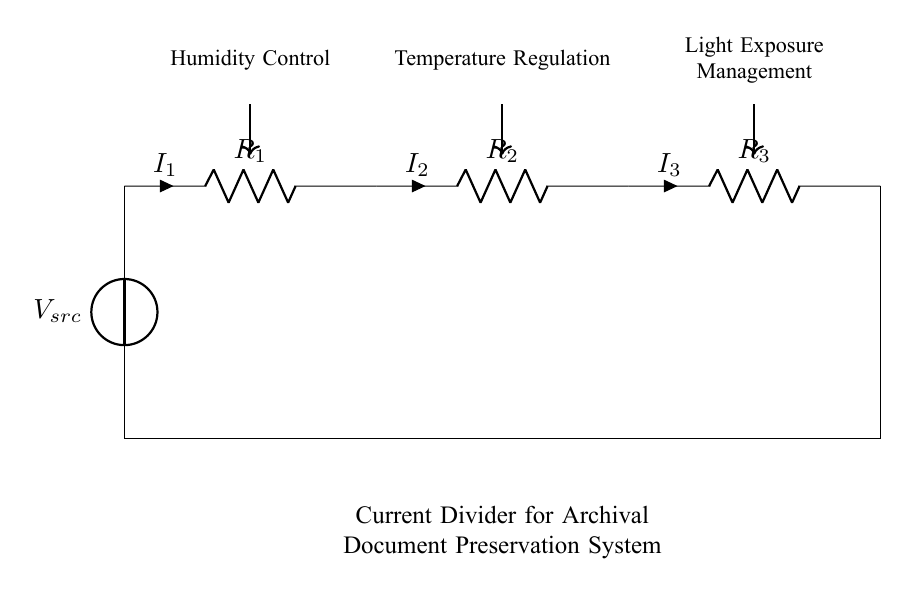What is the type of this circuit? The circuit is a current divider since it splits the total current into smaller currents across multiple resistors in parallel.
Answer: Current divider What components are present in this circuit? The key components in this circuit are resistors and a voltage source; the resistors are labeled R1, R2, and R3, and there is a voltage source Vsrc.
Answer: Resistors and a voltage source How many resistors are involved in the current division? There are three resistors labeled R1, R2, and R3 involved in the current division of the circuit.
Answer: Three resistors What does the diagram illustrate in relation to archival preservation? The diagram illustrates the management of environmental factors such as humidity, temperature, and light exposure for preserving archival documents.
Answer: Environmental management Which resistor would receive the most current? The resistor with the lowest resistance value will receive the most current; however, specific resistance values are not provided in the illustration.
Answer: Lowest resistor (not specified) What is the purpose of a current divider in this context? The purpose is to ensure that the components regulating humidity, temperature, and light exposure can effectively manage their respective conditions while sharing a common current source.
Answer: Effective regulation 